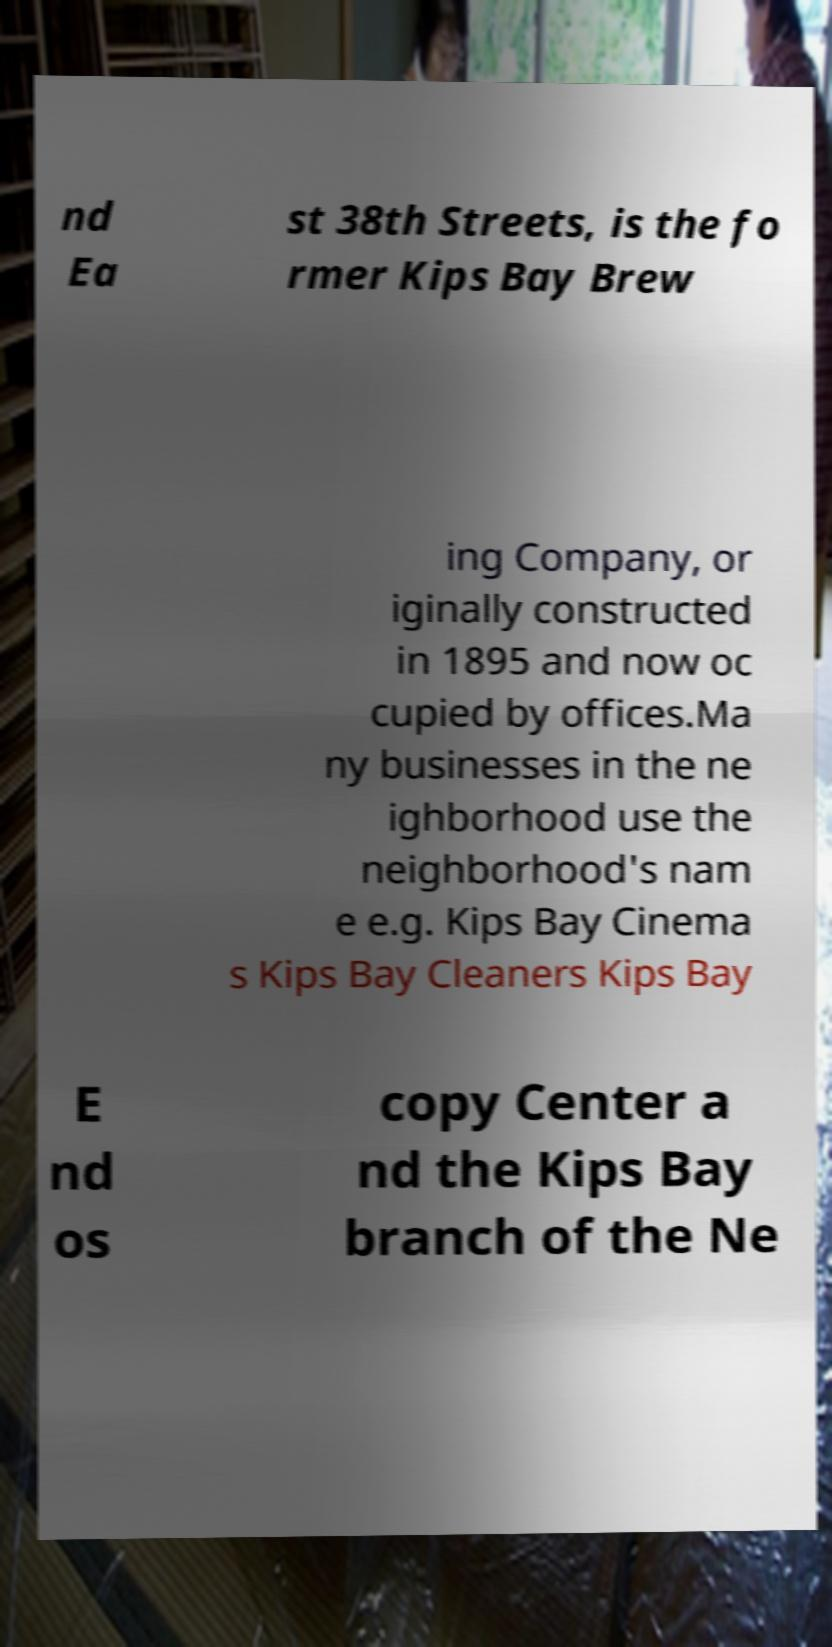Please read and relay the text visible in this image. What does it say? nd Ea st 38th Streets, is the fo rmer Kips Bay Brew ing Company, or iginally constructed in 1895 and now oc cupied by offices.Ma ny businesses in the ne ighborhood use the neighborhood's nam e e.g. Kips Bay Cinema s Kips Bay Cleaners Kips Bay E nd os copy Center a nd the Kips Bay branch of the Ne 